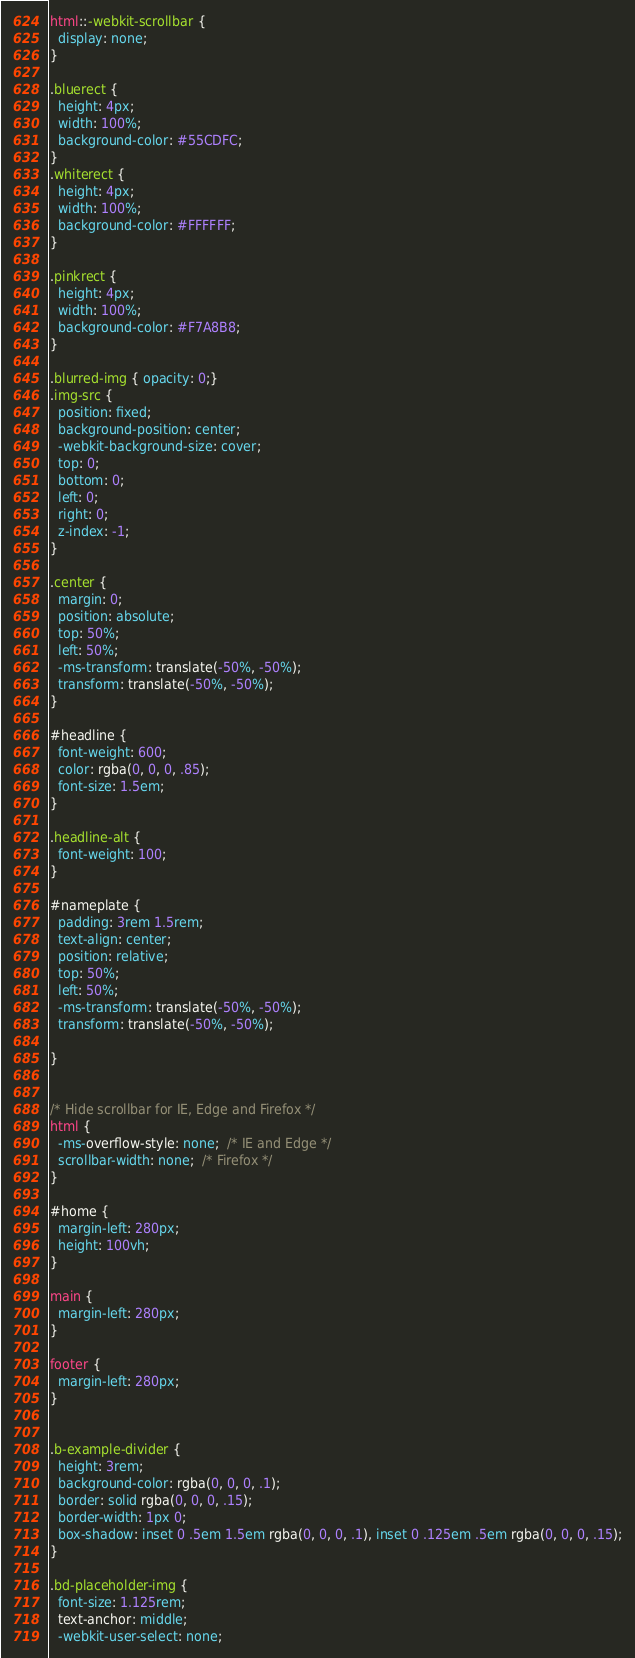<code> <loc_0><loc_0><loc_500><loc_500><_CSS_>html::-webkit-scrollbar {
  display: none;
}

.bluerect {
  height: 4px;
  width: 100%;
  background-color: #55CDFC;
}
.whiterect {
  height: 4px;
  width: 100%;
  background-color: #FFFFFF;
}

.pinkrect {
  height: 4px;
  width: 100%;
  background-color: #F7A8B8;
}

.blurred-img { opacity: 0;}
.img-src {
  position: fixed;
  background-position: center;
  -webkit-background-size: cover;
  top: 0;
  bottom: 0;
  left: 0;
  right: 0;
  z-index: -1;
}

.center {
  margin: 0;
  position: absolute;
  top: 50%;
  left: 50%;
  -ms-transform: translate(-50%, -50%);
  transform: translate(-50%, -50%);
}

#headline {
  font-weight: 600; 
  color: rgba(0, 0, 0, .85); 
  font-size: 1.5em;
}

.headline-alt {
  font-weight: 100;
}

#nameplate {
  padding: 3rem 1.5rem;
  text-align: center;
  position: relative;
  top: 50%;
  left: 50%;
  -ms-transform: translate(-50%, -50%);
  transform: translate(-50%, -50%);

}


/* Hide scrollbar for IE, Edge and Firefox */
html {
  -ms-overflow-style: none;  /* IE and Edge */
  scrollbar-width: none;  /* Firefox */
}

#home {
  margin-left: 280px;
  height: 100vh;
}

main {
  margin-left: 280px;
}

footer {
  margin-left: 280px;
}


.b-example-divider {
  height: 3rem;
  background-color: rgba(0, 0, 0, .1);
  border: solid rgba(0, 0, 0, .15);
  border-width: 1px 0;
  box-shadow: inset 0 .5em 1.5em rgba(0, 0, 0, .1), inset 0 .125em .5em rgba(0, 0, 0, .15);
}

.bd-placeholder-img {
  font-size: 1.125rem;
  text-anchor: middle;
  -webkit-user-select: none;</code> 